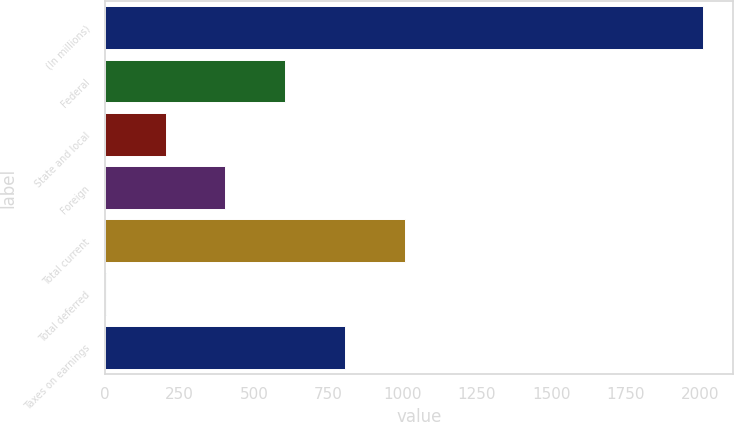Convert chart to OTSL. <chart><loc_0><loc_0><loc_500><loc_500><bar_chart><fcel>(In millions)<fcel>Federal<fcel>State and local<fcel>Foreign<fcel>Total current<fcel>Total deferred<fcel>Taxes on earnings<nl><fcel>2012<fcel>605.28<fcel>203.36<fcel>404.32<fcel>1007.2<fcel>2.4<fcel>806.24<nl></chart> 